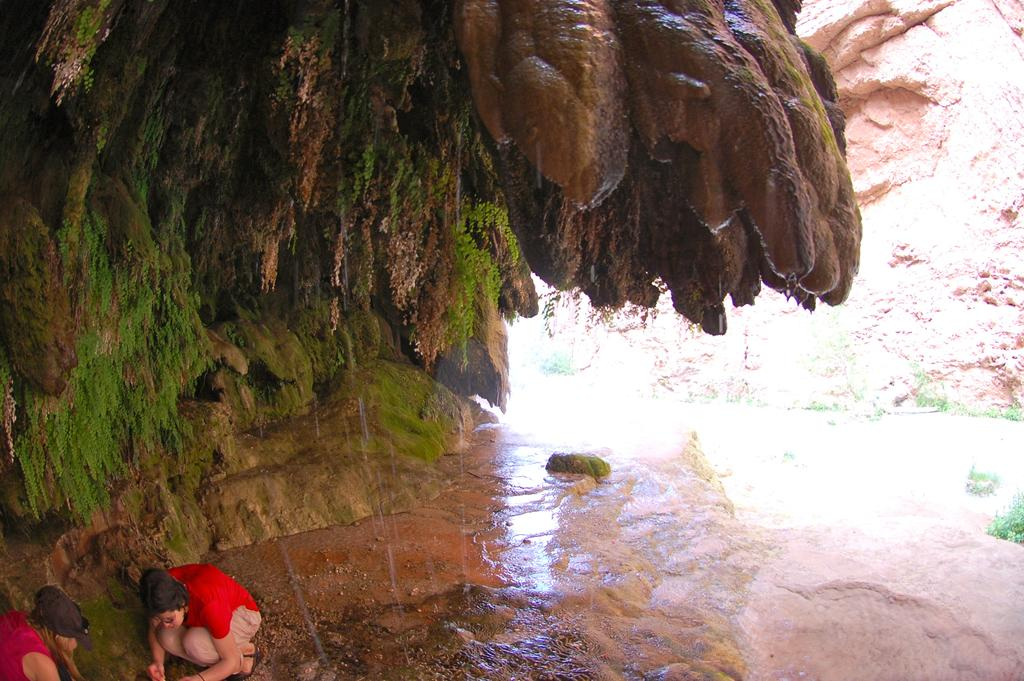How many people are in the image? There are two people in the image. What position are the people in? The two people are in a squat position. What can be seen in the image besides the people? There is water visible in the image. What is visible in the background of the image? There are hills in the background of the image. What type of root can be seen growing in the water in the image? There is no root visible in the image; it only shows two people in a squat position and water. 